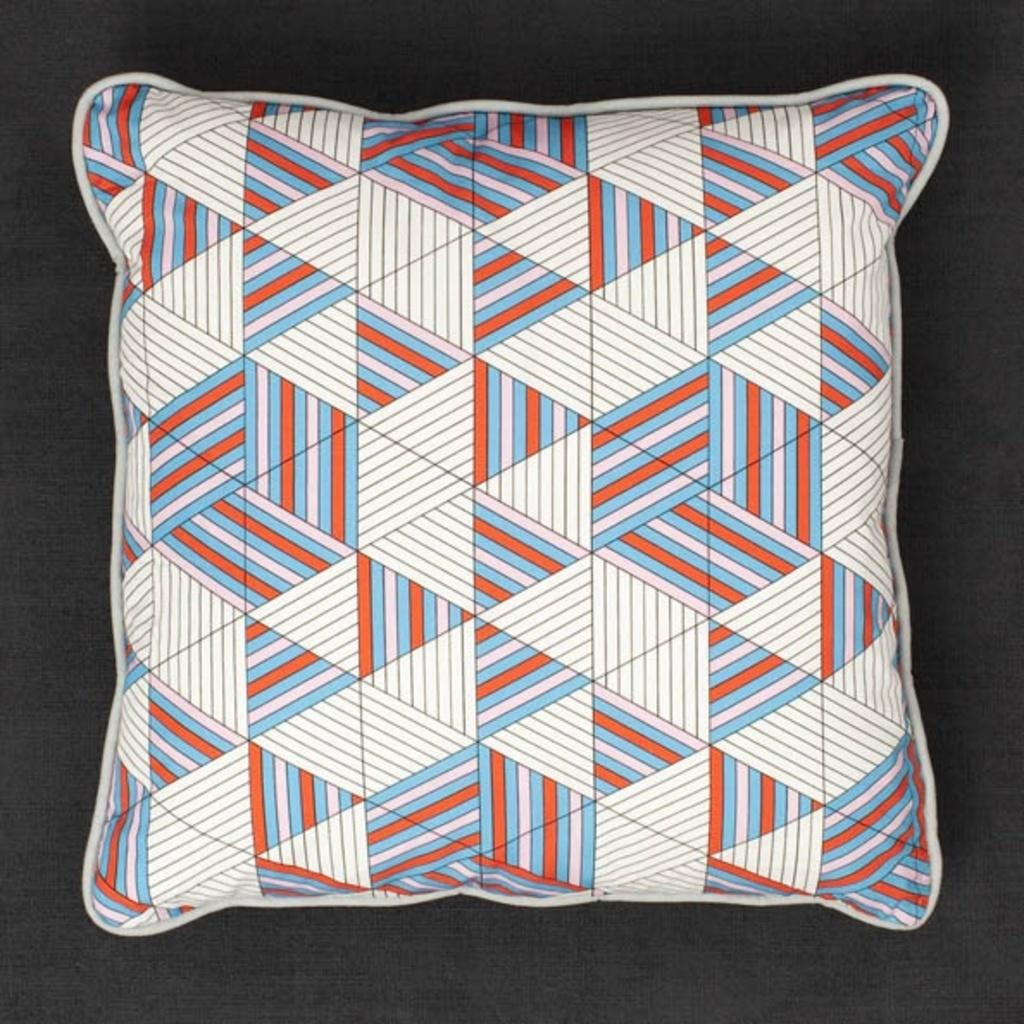What object is present in the image? There is a pillow in the image. What is the pillow placed on in the image? The pillow is on a black surface. How many seeds are visible on the pillow in the image? There are no seeds visible on the pillow in the image. Is there a jail present in the image? There is no jail present in the image. What type of calculator is being used on the pillow in the image? There is no calculator present on the pillow in the image. 